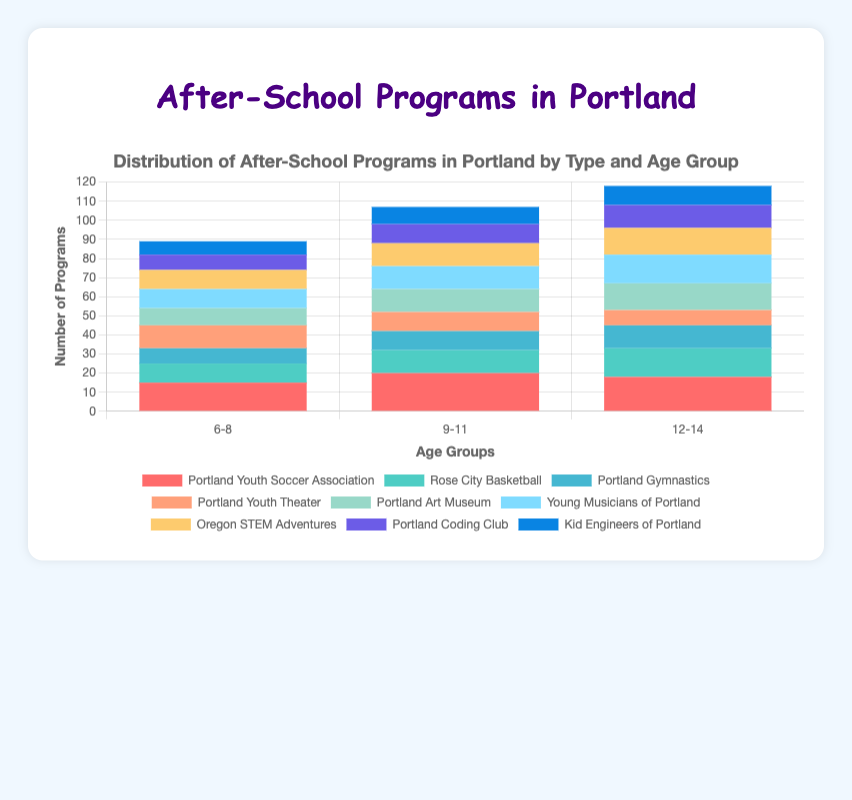What age group has the most diverse STEM programs? To determine the age group with the most diverse STEM programs, we compare the different programs offered within each age group for STEM. Here:
    - Age 6-8: 3 programs
    - Age 9-11: 3 programs
    - Age 12-14: 3 programs
All age groups have exactly 3 different STEM programs, hence they are equally diverse.
Answer: All age groups are equally diverse Which Arts program has the highest number of offerings for the age group 12-14? For the age group 12-14 within Arts:
    - Portland Youth Theater: 8 programs
    - Portland Art Museum: 14 programs
    - Young Musicians of Portland: 15 programs
Young Musicians of Portland has the highest number of offerings.
Answer: Young Musicians of Portland What is the total number of sports programs available for the age group 9-11? For the age group 9-11 within sports:
    - Portland Youth Soccer Association: 20 programs
    - Rose City Basketball: 12 programs
    - Portland Gymnastics: 10 programs
The total number is 20 + 12 + 10 = 42 programs.
Answer: 42 How many more programs does Oregon STEM Adventures offer for age group 12-14 compared to Kid Engineers of Portland for the same age group? For age group 12-14:
    - Oregon STEM Adventures: 14 programs
    - Kid Engineers of Portland: 10 programs
The difference is 14 - 10 = 4 programs.
Answer: 4 Which age group has the highest number of total sports programs offered? Summing up sports programs for each age group:
    - Age 6-8: 15 + 10 + 8 = 33 programs
    - Age 9-11: 20 + 12 + 10 = 42 programs
    - Age 12-14: 18 + 15 + 12 = 45 programs
The age group 12-14 has the highest number of total sports programs.
Answer: 12-14 Which type of program has the highest total number of offerings for the age group 6-8? Summing up the total programs for each type in age group 6-8:
    - Sports: 15 + 10 + 8 = 33 programs
    - Arts: 12 + 9 + 10 = 31 programs
    - STEM: 10 + 8 + 7 = 25 programs
Sports has the highest total number of offerings.
Answer: Sports Which program is represented by the green bar in the chart? Referring to typical color-coding in the plot and verifying against the dataset, it is found that the green bar represents Portland Gymnastics.
Answer: Portland Gymnastics Which type of program has the most significant increase in offerings from the age group 6-8 to 9-11? Evaluate each type:
    - Sports: 42 (9-11) - 33 (6-8) = 9 programs increase
    - Arts: 34 (9-11) - 31 (6-8) = 3 programs increase
    - STEM: 31 (9-11) - 25 (6-8) = 6 programs increase
Sports has the most significant increase.
Answer: Sports 